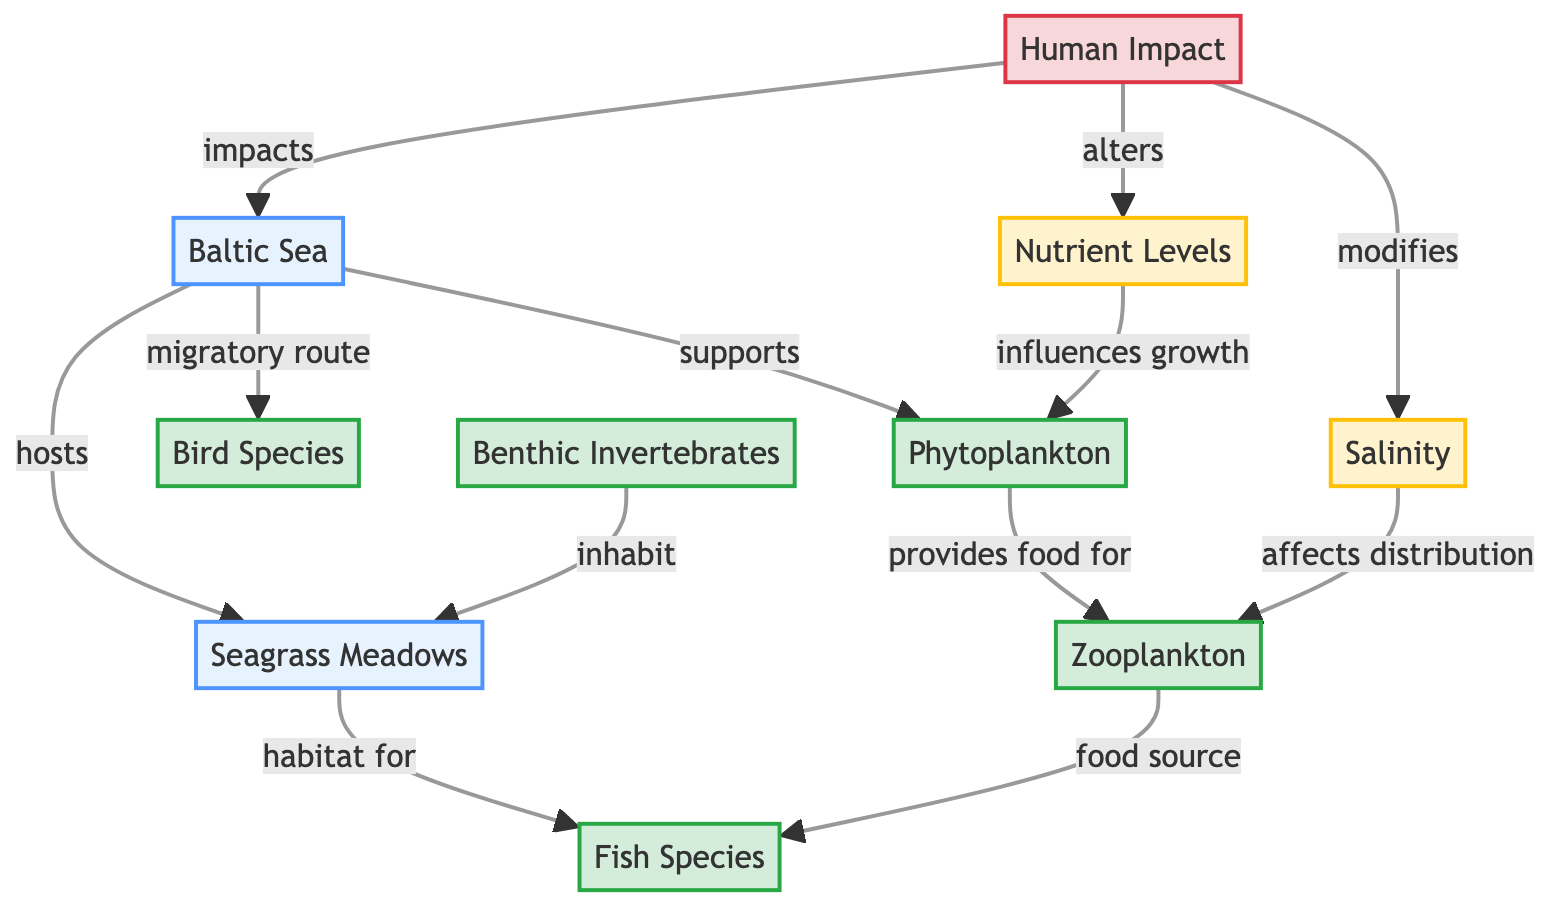What ecosystem is represented at the top of the diagram? The topmost node is labeled "Baltic Sea," which identifies the ecosystem under discussion.
Answer: Baltic Sea How many organism types are listed in the diagram? The diagram lists four distinct organism types: phytoplankton, zooplankton, fish species, and benthic invertebrates.
Answer: Four What type of environmental factor influences phytoplankton growth? The flow from the nutrient levels node indicates that nutrient levels influence the growth of phytoplankton.
Answer: Nutrient levels Which organism provides food for zooplankton? The arrow from phytoplankton shows that it provides food for zooplankton.
Answer: Phytoplankton What is one of the human impacts mentioned in the diagram? The diagram indicates "Human Impact" as an overarching factor that influences various aspects of the ecosystem, including the Baltic Sea itself.
Answer: Human Impact How does salinity affect zooplankton? The diagram states that salinity affects the distribution of zooplankton, showing a direct relationship between these two nodes.
Answer: Affects distribution Which organism is identified as a habitat for fish species? The arrow from the seagrass meadows node indicates that it serves as a habitat for fish species.
Answer: Seagrass Meadows What relationship exists between zooplankton and fish species? The diagram shows that zooplankton is a food source for fish species, indicating a predator-prey relationship within the ecosystem.
Answer: Food source In the context of this diagram, what serves as a migratory route for bird species? The connection indicates that the Baltic Sea serves as a migratory route for bird species, highlighting its importance for avian migration.
Answer: Baltic Sea 